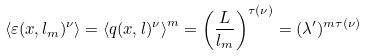Convert formula to latex. <formula><loc_0><loc_0><loc_500><loc_500>\left \langle \varepsilon ( x , l _ { m } ) ^ { \nu } \right \rangle = \left \langle q ( x , l ) ^ { \nu } \right \rangle ^ { m } = \left ( \frac { L } { l _ { m } } \right ) ^ { \tau ( \nu ) } = ( \lambda ^ { \prime } ) ^ { m \tau ( \nu ) }</formula> 